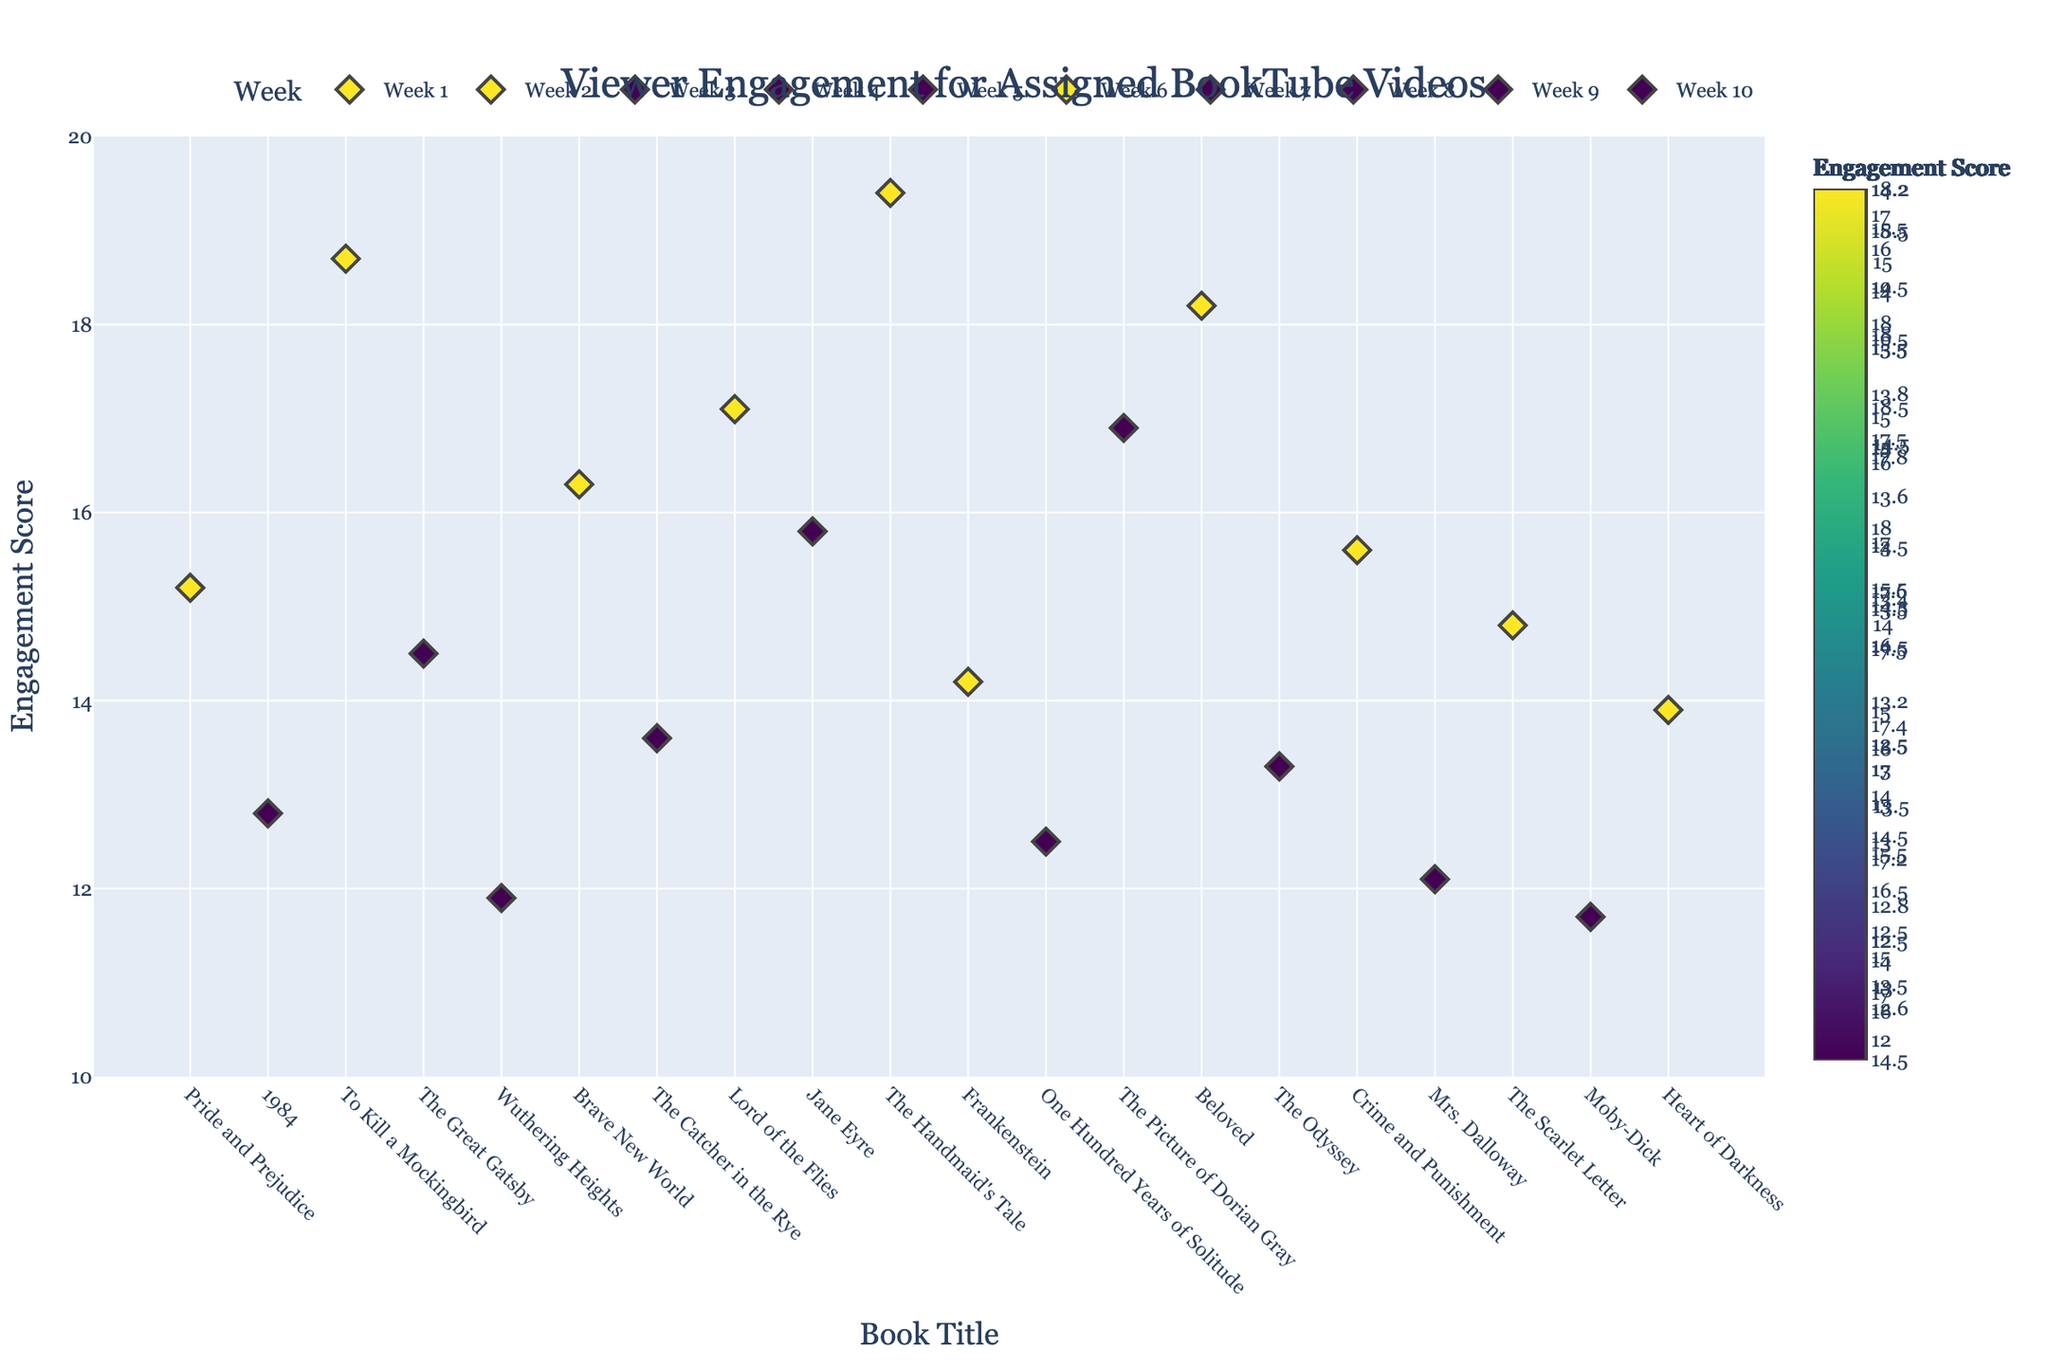What's the title of the plot? The title of any plot is typically found at the top of the figure and provides a summary of what the plot represents. Here, the title is "Viewer Engagement for Assigned BookTube Videos," which is displayed prominently at the top center of the plot.
Answer: Viewer Engagement for Assigned BookTube Videos What's the engagement score of "Beloved by Toni Morrison"? Locate "Beloved by Toni Morrison" on the x-axis, then trace vertically to find its corresponding engagement score on the y-axis. The point falls at 18.2.
Answer: 18.2 Which book had the highest engagement score? To find the highest engagement score, look at the y-axis for the point at the maximum position. Cross-referencing it with the x-axis shows "The Handmaid's Tale by Margaret Atwood" has the highest engagement score of 19.4.
Answer: The Handmaid's Tale by Margaret Atwood What was the average engagement score for Week 1? Identify the points for Week 1 ("Pride and Prejudice by Jane Austen" and "1984 by George Orwell") and note their engagement scores (15.2 and 12.8, respectively). Calculate the average: (15.2 + 12.8) / 2 = 14.
Answer: 14 Which week had the lowest minimum engagement score, and what was it? Examine each week's points to find the minimum engagement score within each week. Week 10 ("Moby-Dick by Herman Melville") has the lowest minimum engagement score of 11.7.
Answer: Week 10, 11.7 Is there any week where both engagement scores were above 15? Check each week’s engagement scores. For Week 5, both "Jane Eyre by Charlotte Bronte" (15.8) and "The Handmaid's Tale by Margaret Atwood" (19.4) have scores above 15.
Answer: Week 5 How many weeks are represented in the plot? Count the distinct weeks displayed on the x-axis. There are 10 unique weeks shown.
Answer: 10 Which book had the closest engagement score to 15? Look for the engagement scores closest to 15. "Crime and Punishment by Fyodor Dostoevsky" has an engagement score of 15.6.
Answer: Crime and Punishment by Fyodor Dostoevsky Which weeks have engagement scores composed of only two-digit numbers? Identify weeks where all engagement scores are between 10 and 20. Weeks 1 through 10 fit this criterion.
Answer: Weeks 1 through 10 